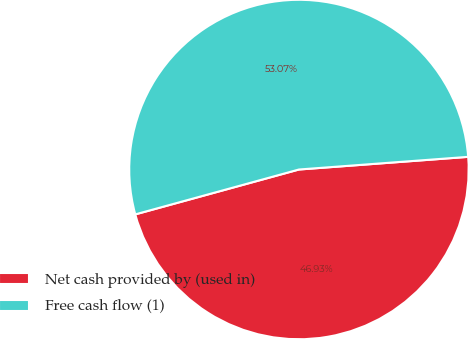<chart> <loc_0><loc_0><loc_500><loc_500><pie_chart><fcel>Net cash provided by (used in)<fcel>Free cash flow (1)<nl><fcel>46.93%<fcel>53.07%<nl></chart> 